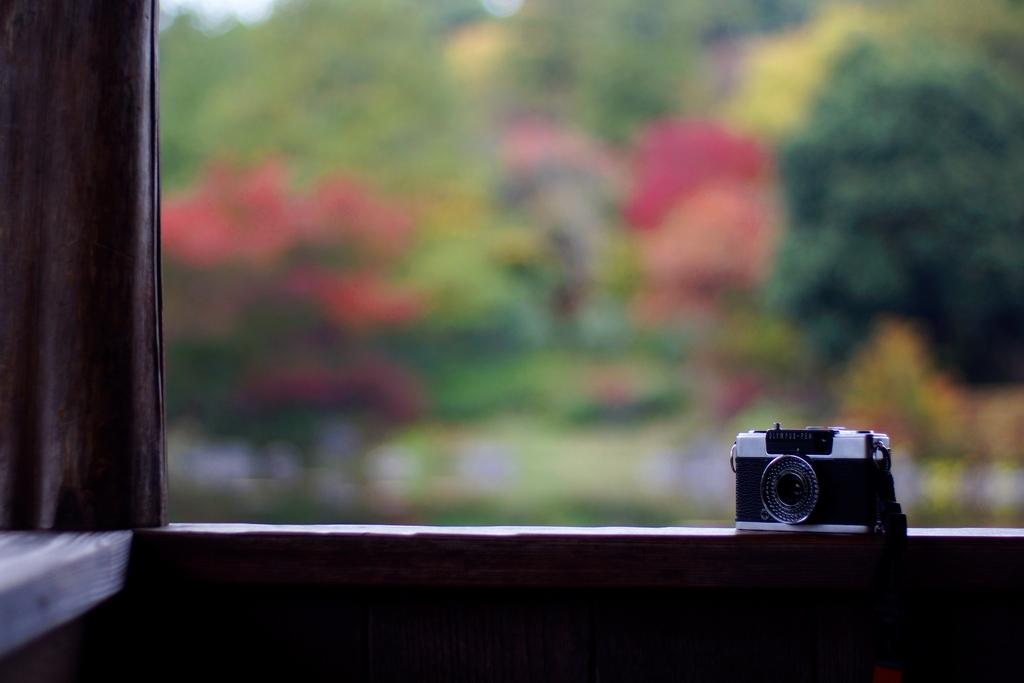What object is the main focus of the image? There is a camera in the image. Where is the camera placed? The camera is on a surface. What can be seen on the left side of the image? There is a cloth on the left side of the image. How would you describe the background of the image? The background of the image is blurred. What type of breakfast is being prepared on the camera in the image? There is no breakfast or preparation of food visible in the image; it features a camera on a surface with a cloth on the left side and a blurred background. 